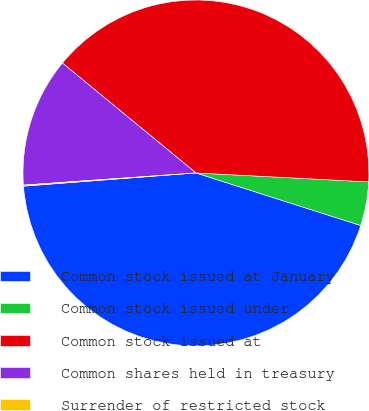<chart> <loc_0><loc_0><loc_500><loc_500><pie_chart><fcel>Common stock issued at January<fcel>Common stock issued under<fcel>Common stock issued at<fcel>Common shares held in treasury<fcel>Surrender of restricted stock<nl><fcel>43.87%<fcel>4.09%<fcel>39.87%<fcel>12.08%<fcel>0.1%<nl></chart> 